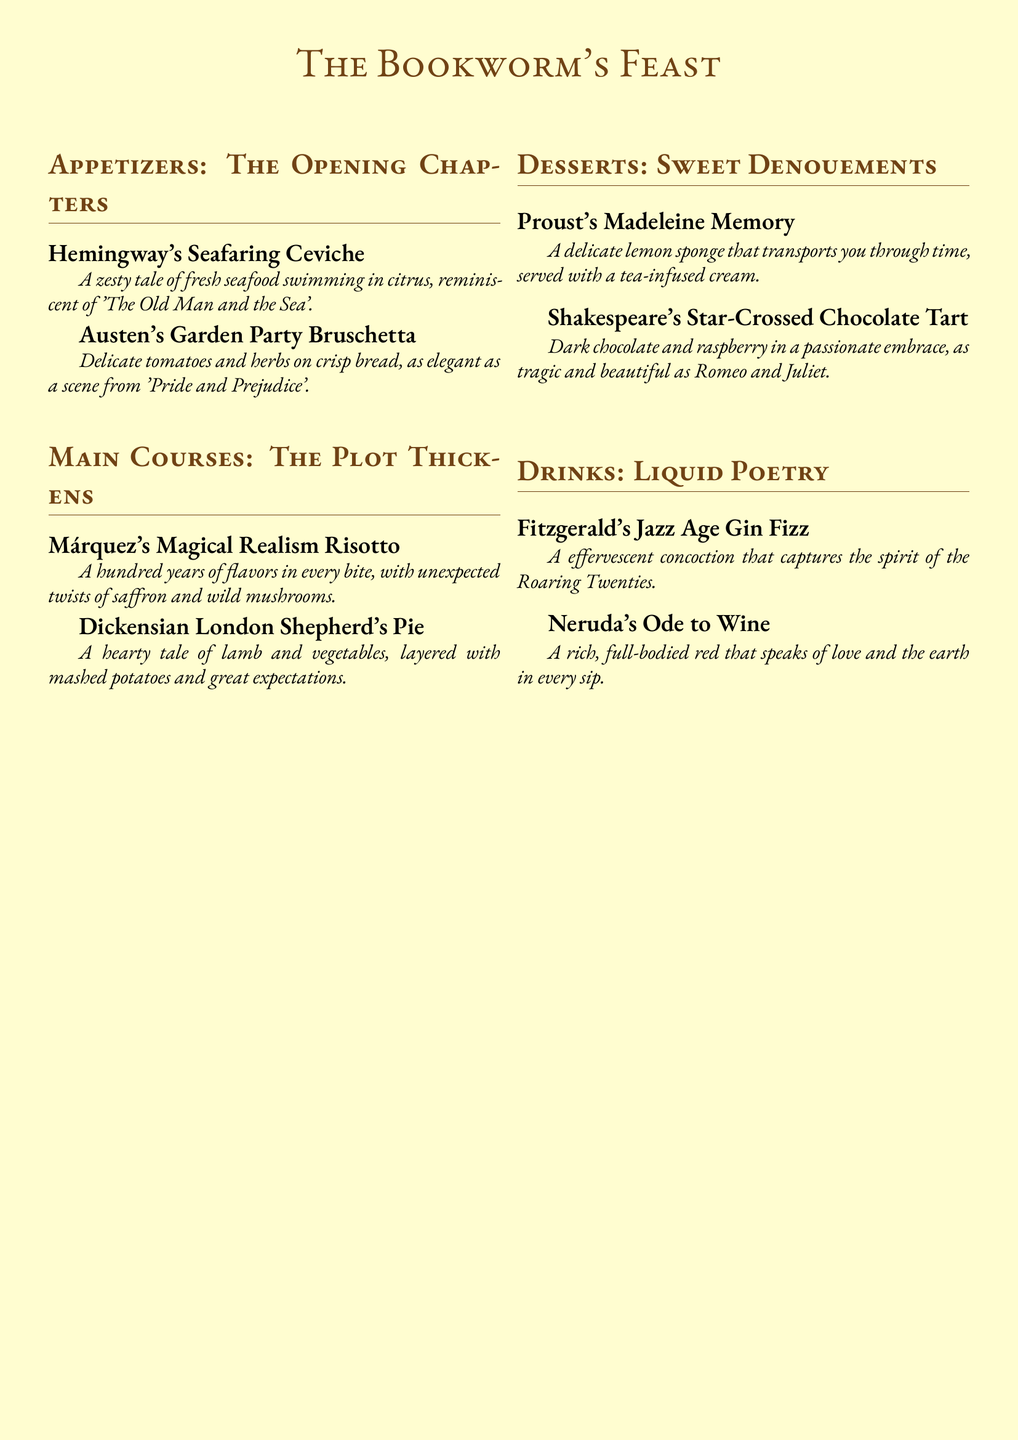What are the appetizers called? The appetizers section is titled "The Opening Chapters."
Answer: The Opening Chapters How many main courses are listed? There are two main courses mentioned in the document.
Answer: 2 What is the name of the dessert that relates to memory? The dessert associated with memory is named after a famous author known for a specific literary piece.
Answer: Proust's Madeleine Memory Which literary period does Fitzgerald's drink represent? Fitzgerald's drink is inspired by a specific time known for cultural change and celebration.
Answer: The Roaring Twenties What main ingredient is found in Márquez's risotto? Márquez's dish contains a distinctive herb that adds a unique flavor.
Answer: Saffron Which appetizer is inspired by Austen? The appetizer influenced by Austen's writing captures the essence of a specific social gathering.
Answer: Austen's Garden Party Bruschetta 